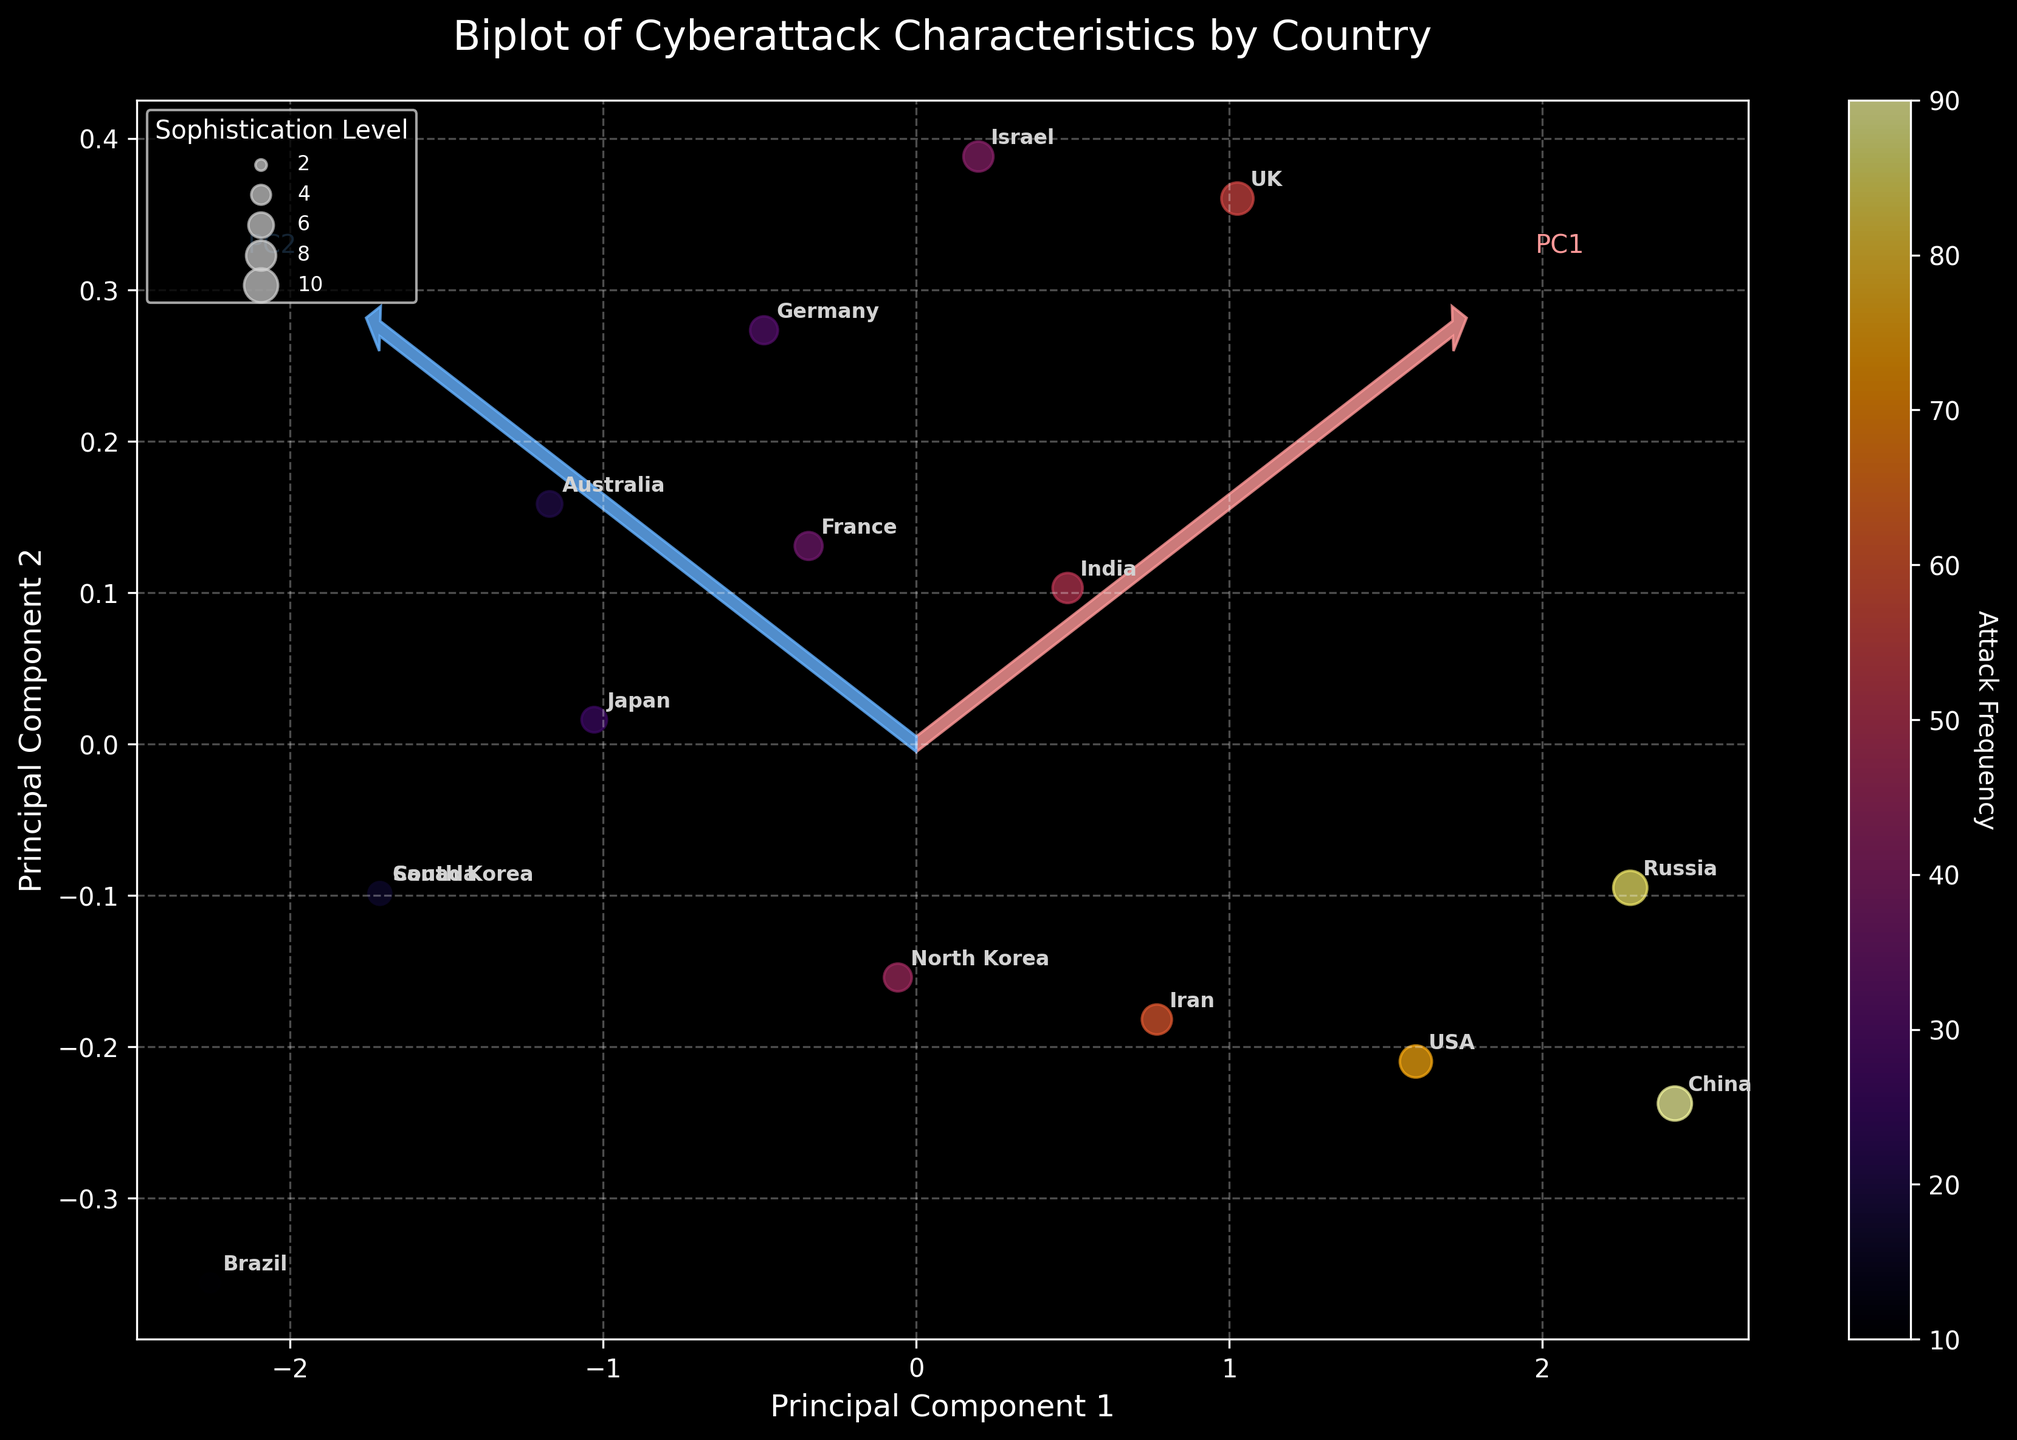How many principal components are displayed in the biplot? The biplot shows two principal components, identified as PC1 and PC2. You can see this as there are two axes marked as "Principal Component 1" and "Principal Component 2."
Answer: Two Which country has the highest attack frequency? The scatter points represent different countries, with their colors indicating the attack frequency. The country in the darkest color (deepest shade in the 'inferno' colormap) has the highest frequency. Observing the plot reveals that China has the highest attack frequency.
Answer: China Which country corresponds to the smallest dot size, and what does that denote about its sophistication level? Looking at the scatter points, the size of each dot is proportional to the sophistication level. The smallest dots represent the countries with the lowest sophistication levels. Examining the plot, Brazil corresponds to the smallest dot size. This denotes a sophistication level of 3, as indicated by the legend.
Answer: Brazil, 3 How is the United Kingdom positioned in relation to the principal components? To determine the UK’s position, find where "UK" is annotated on the plot relative to PC1 and PC2. The UK is located towards the negative side of PC1 and slightly positive on PC2, indicating its placement in the respective components.
Answer: Negative PC1, Slightly positive PC2 Which sector is targeted by the country with the second-highest sophistication level? The sectors are indicated by countries that target them, and the sophistication level is shown by the point size. The second-highest sophistication level corresponds to Russia. Russia targets the Energy sector, as seen from its label.
Answer: Energy Comparing USA and Israel, which country has a higher attack frequency and by how much? Observing their positions and respective colors on the scatter plot reveals that the USA has a higher attack frequency than Israel. The color bar shows USA’s darker shade implying higher frequency. Comparing them directly using the data indicates USA has 75 and Israel has 40, resulting in a difference of 35 attack frequency.
Answer: USA, by 35 Do the arrows of the eigenvectors align more with the plot’s PC1 or PC2 axis? Observing the biplot, the arrows representing the eigenvectors emanate from the origin and point towards the axes conveying directions. They align more with the axes marked as PC1 and PC2, confirming their alignment.
Answer: Both PC1 and PC2 Which principal component is more closely associated with sophistication level, and how can you tell? To determine the association, observe the direction of eigenvectors corresponding to high sophistication levels. A closer look shows that the arrows diverging from the eigenvector marked as PC2 correspond tightly to dots representing higher sophistication levels, confirming this association.
Answer: PC2 